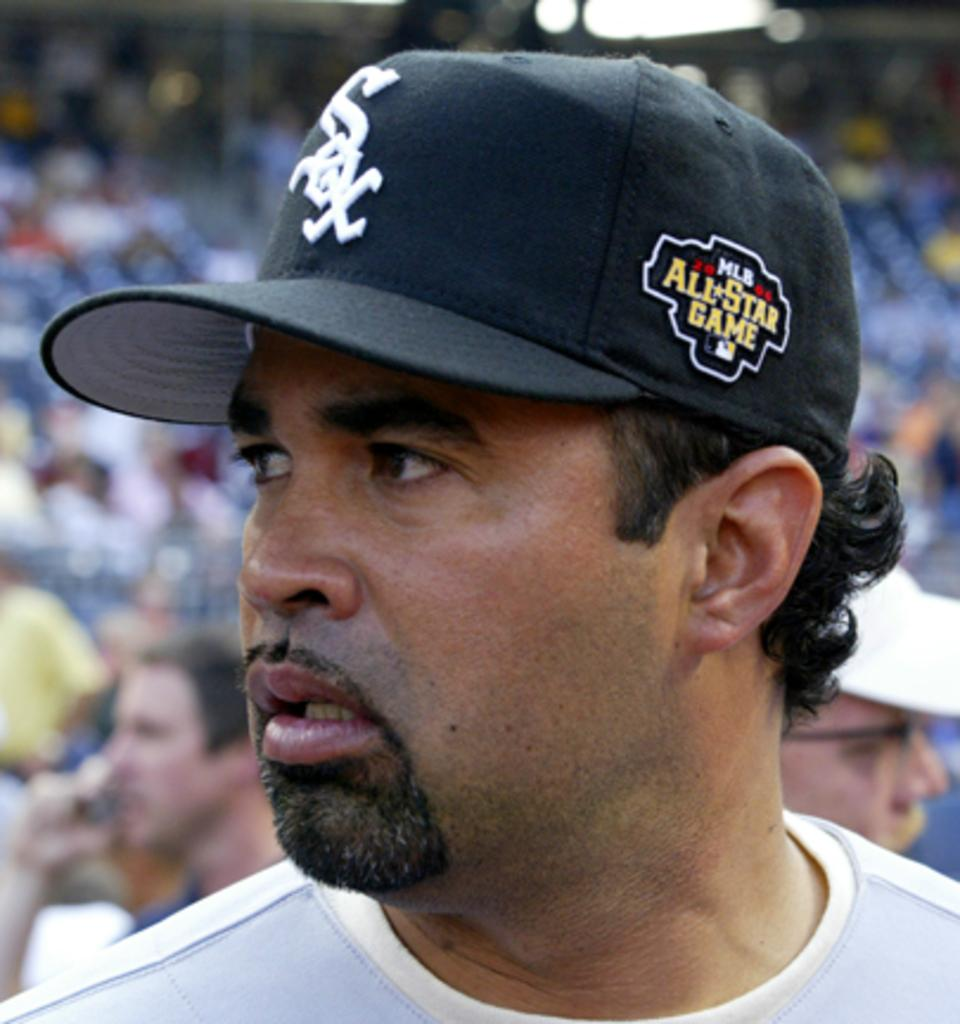<image>
Describe the image concisely. a man in a goatee wearing a Sox MLB All-Star Game hat 